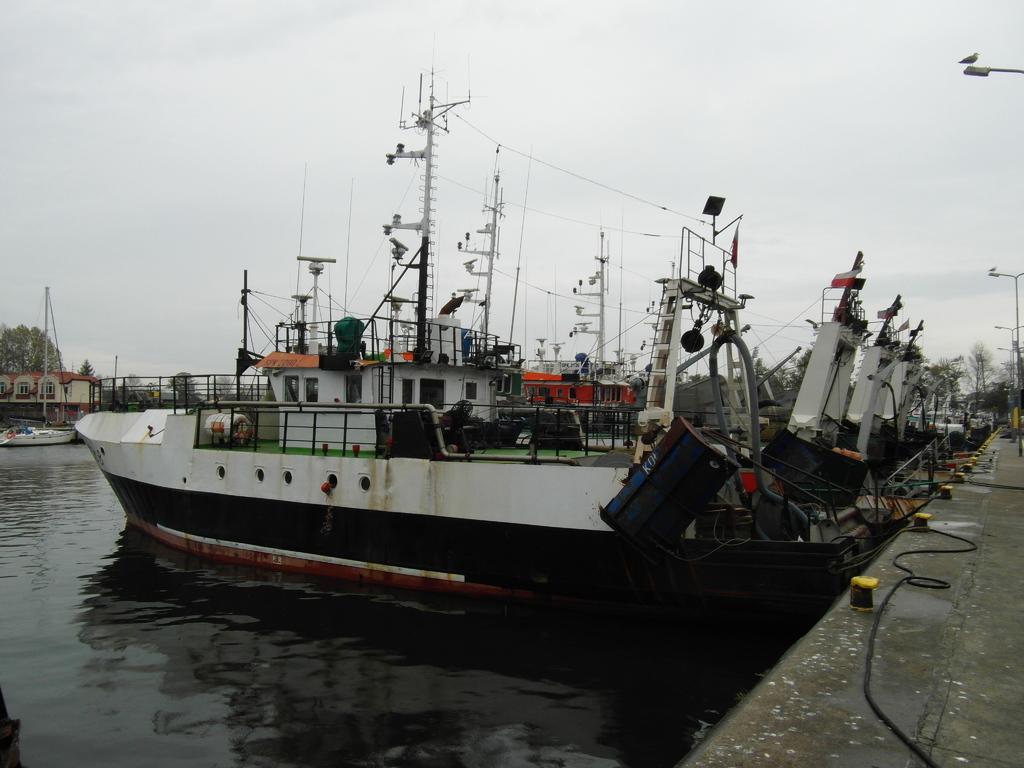Can you describe this image briefly? In this image I can see the water, few boats on the surface of the water, a bridge, few poles, few ropes, few trees and few buildings. In the background I can see the sky. 